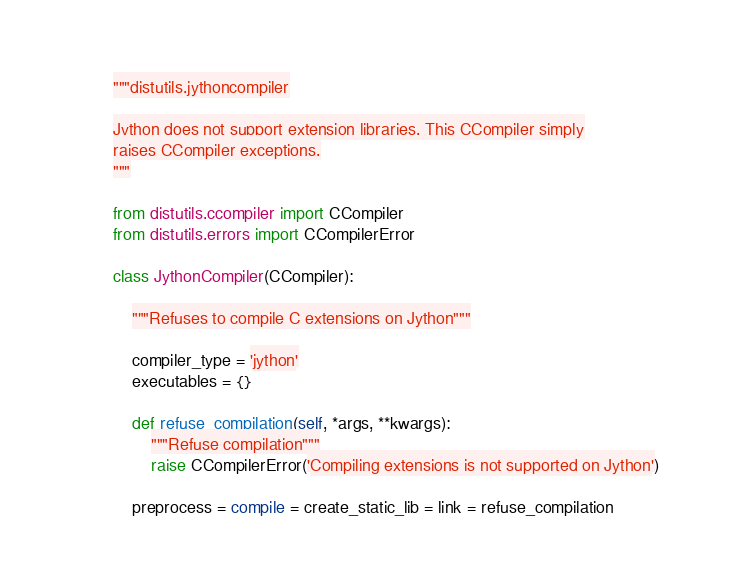<code> <loc_0><loc_0><loc_500><loc_500><_Python_>"""distutils.jythoncompiler

Jython does not support extension libraries. This CCompiler simply
raises CCompiler exceptions.
"""

from distutils.ccompiler import CCompiler
from distutils.errors import CCompilerError

class JythonCompiler(CCompiler):

    """Refuses to compile C extensions on Jython"""

    compiler_type = 'jython'
    executables = {}

    def refuse_compilation(self, *args, **kwargs):
        """Refuse compilation"""
        raise CCompilerError('Compiling extensions is not supported on Jython')

    preprocess = compile = create_static_lib = link = refuse_compilation
</code> 